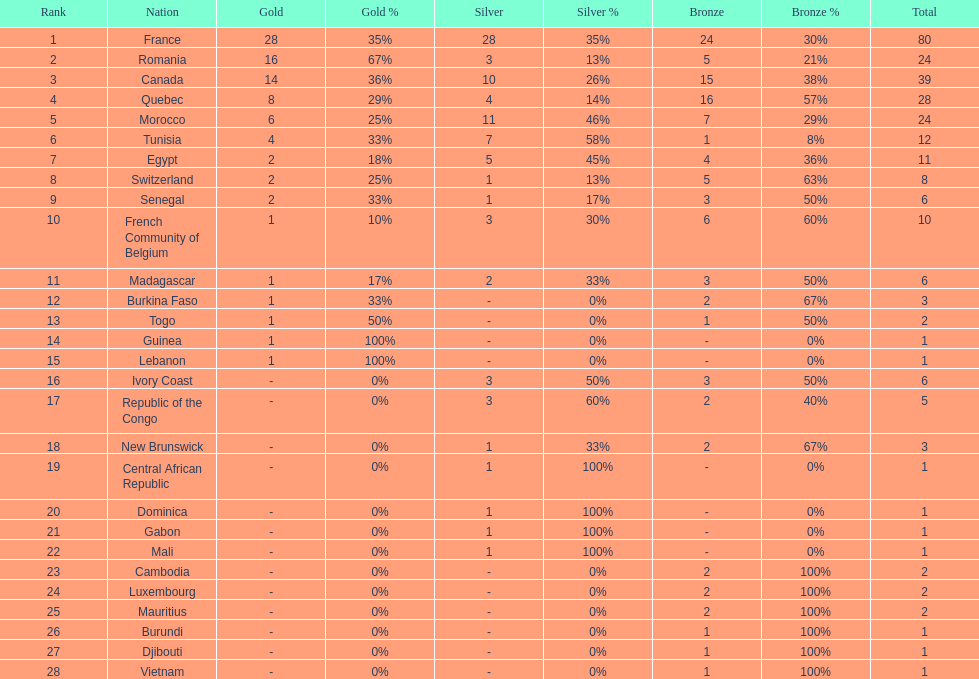Can you give me this table as a dict? {'header': ['Rank', 'Nation', 'Gold', 'Gold %', 'Silver', 'Silver %', 'Bronze', 'Bronze %', 'Total'], 'rows': [['1', 'France', '28', '35%', '28', '35%', '24', '30%', '80'], ['2', 'Romania', '16', '67%', '3', '13%', '5', '21%', '24'], ['3', 'Canada', '14', '36%', '10', '26%', '15', '38%', '39'], ['4', 'Quebec', '8', '29%', '4', '14%', '16', '57%', '28'], ['5', 'Morocco', '6', '25%', '11', '46%', '7', '29%', '24'], ['6', 'Tunisia', '4', '33%', '7', '58%', '1', '8%', '12'], ['7', 'Egypt', '2', '18%', '5', '45%', '4', '36%', '11'], ['8', 'Switzerland', '2', '25%', '1', '13%', '5', '63%', '8'], ['9', 'Senegal', '2', '33%', '1', '17%', '3', '50%', '6'], ['10', 'French Community of Belgium', '1', '10%', '3', '30%', '6', '60%', '10'], ['11', 'Madagascar', '1', '17%', '2', '33%', '3', '50%', '6'], ['12', 'Burkina Faso', '1', '33%', '-', '0%', '2', '67%', '3'], ['13', 'Togo', '1', '50%', '-', '0%', '1', '50%', '2'], ['14', 'Guinea', '1', '100%', '-', '0%', '-', '0%', '1'], ['15', 'Lebanon', '1', '100%', '-', '0%', '-', '0%', '1'], ['16', 'Ivory Coast', '-', '0%', '3', '50%', '3', '50%', '6'], ['17', 'Republic of the Congo', '-', '0%', '3', '60%', '2', '40%', '5'], ['18', 'New Brunswick', '-', '0%', '1', '33%', '2', '67%', '3'], ['19', 'Central African Republic', '-', '0%', '1', '100%', '-', '0%', '1'], ['20', 'Dominica', '-', '0%', '1', '100%', '-', '0%', '1'], ['21', 'Gabon', '-', '0%', '1', '100%', '-', '0%', '1'], ['22', 'Mali', '-', '0%', '1', '100%', '-', '0%', '1'], ['23', 'Cambodia', '-', '0%', '-', '0%', '2', '100%', '2'], ['24', 'Luxembourg', '-', '0%', '-', '0%', '2', '100%', '2'], ['25', 'Mauritius', '-', '0%', '-', '0%', '2', '100%', '2'], ['26', 'Burundi', '-', '0%', '-', '0%', '1', '100%', '1'], ['27', 'Djibouti', '-', '0%', '-', '0%', '1', '100%', '1'], ['28', 'Vietnam', '-', '0%', '-', '0%', '1', '100%', '1']]} How many nations won at least 10 medals? 8. 